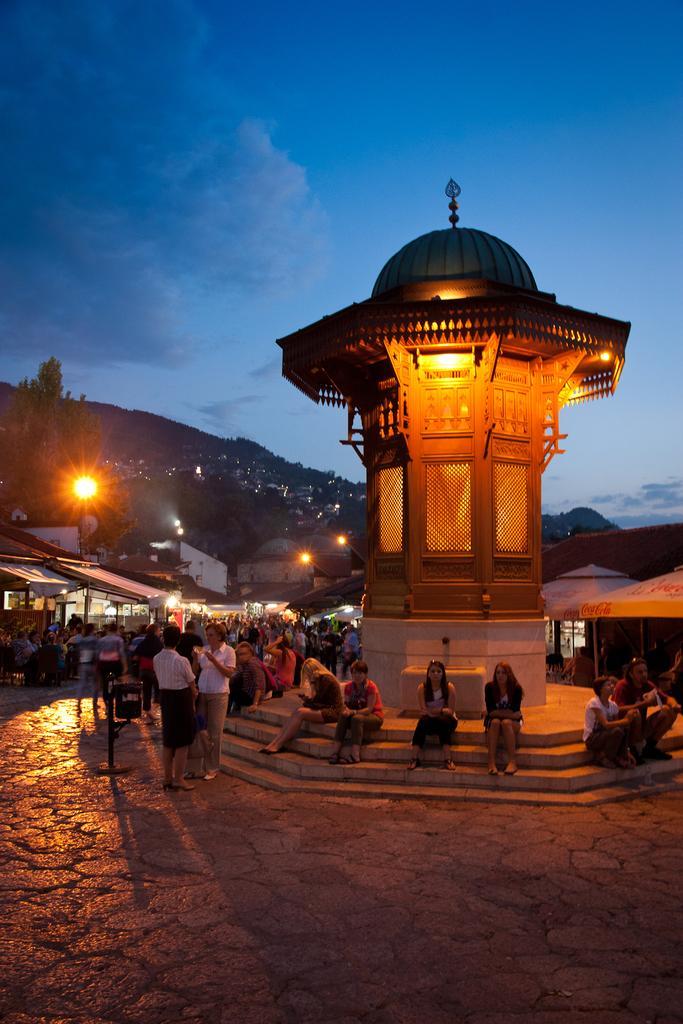How would you summarize this image in a sentence or two? In this picture I can see a tower and few houses and I can see few people are seated and few are standing and I can see pole lights and few trees and I can see hill and a blue cloudy sky. 